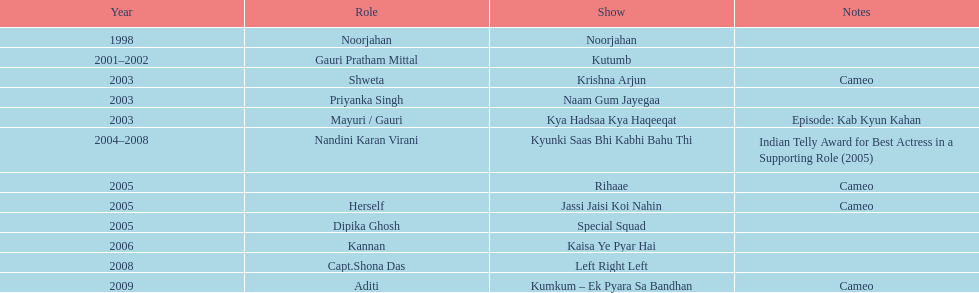In relation to "left right left," where is the show situated above it? Kaisa Ye Pyar Hai. 